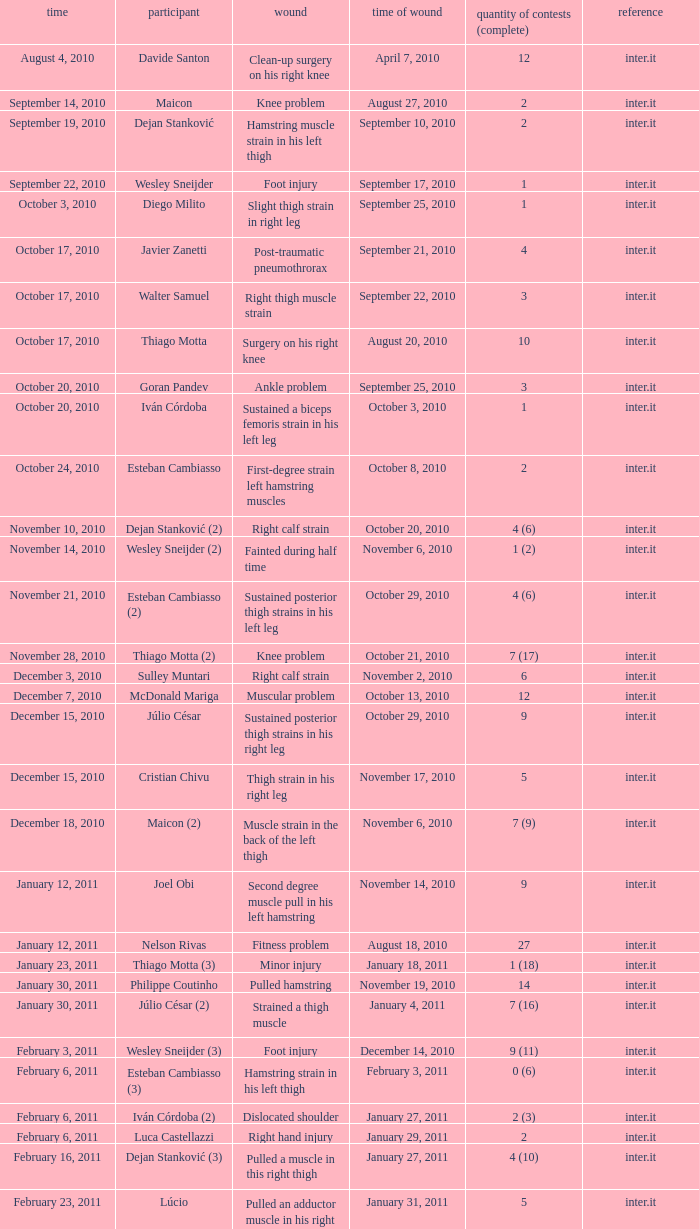How many times was the date october 3, 2010? 1.0. 